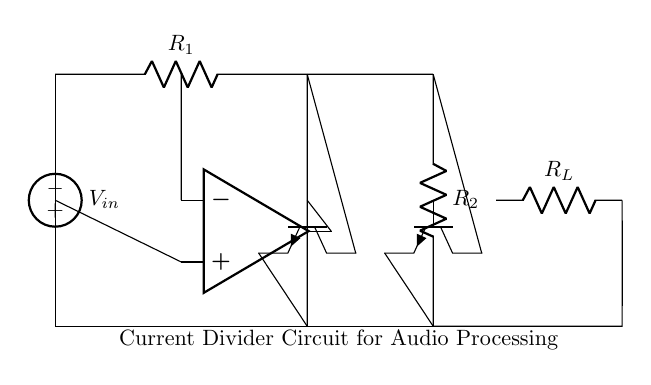What is the type of input voltage source? The input voltage source is an American voltage source, indicated by the symbol in the circuit diagram.
Answer: American voltage source What are the values of resistors R1 and R2? The values of R1 and R2 are not specified in the circuit diagram. However, they are marked as R1 and R2, indicating they are resistors used in this current divider configuration.
Answer: Not specified Which components are used to create the current divider? The current divider in this circuit is created using resistors R1, R2, and two transistors (Q1 and Q2).
Answer: Resistors R1, R2, and transistors Q1, Q2 What is the role of the op-amp in this circuit? The op-amp functions as an amplifier or signal processor, which can influence the current division based on its gain characteristics. It amplifies the difference between its two input terminals, impacting the currents through R1 and R2.
Answer: Amplifier or signal processor How does the current divider work in relation to the load resistor? The current divider works by splitting the total input current into parts that flow through R1 and R2, consequently affecting the current flowing through the load resistor (R_L) based on the values of R1 and R2. The division is determined by the ratio of the resistances.
Answer: By splitting current based on resistor values What happens to the output current if R1 is smaller than R2? If R1 is smaller than R2, more current will flow through R1 than through R2 according to the current divider rule; therefore, the output current towards the load would be larger as it is influenced mainly by R1.
Answer: More current to R1 